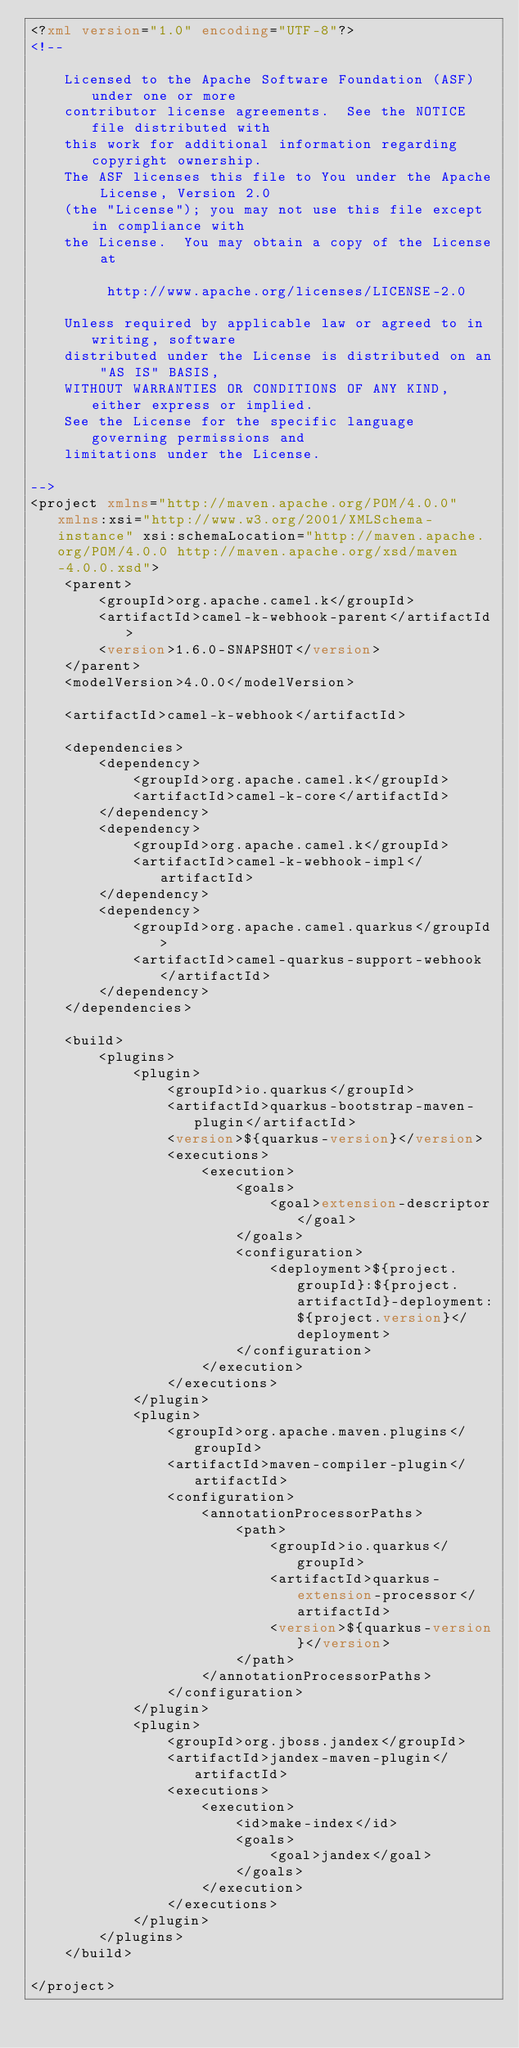<code> <loc_0><loc_0><loc_500><loc_500><_XML_><?xml version="1.0" encoding="UTF-8"?>
<!--

    Licensed to the Apache Software Foundation (ASF) under one or more
    contributor license agreements.  See the NOTICE file distributed with
    this work for additional information regarding copyright ownership.
    The ASF licenses this file to You under the Apache License, Version 2.0
    (the "License"); you may not use this file except in compliance with
    the License.  You may obtain a copy of the License at

         http://www.apache.org/licenses/LICENSE-2.0

    Unless required by applicable law or agreed to in writing, software
    distributed under the License is distributed on an "AS IS" BASIS,
    WITHOUT WARRANTIES OR CONDITIONS OF ANY KIND, either express or implied.
    See the License for the specific language governing permissions and
    limitations under the License.

-->
<project xmlns="http://maven.apache.org/POM/4.0.0" xmlns:xsi="http://www.w3.org/2001/XMLSchema-instance" xsi:schemaLocation="http://maven.apache.org/POM/4.0.0 http://maven.apache.org/xsd/maven-4.0.0.xsd">
    <parent>
        <groupId>org.apache.camel.k</groupId>
        <artifactId>camel-k-webhook-parent</artifactId>
        <version>1.6.0-SNAPSHOT</version>
    </parent>
    <modelVersion>4.0.0</modelVersion>

    <artifactId>camel-k-webhook</artifactId>

    <dependencies>
        <dependency>
            <groupId>org.apache.camel.k</groupId>
            <artifactId>camel-k-core</artifactId>
        </dependency>
        <dependency>
            <groupId>org.apache.camel.k</groupId>
            <artifactId>camel-k-webhook-impl</artifactId>
        </dependency>
        <dependency>
            <groupId>org.apache.camel.quarkus</groupId>
            <artifactId>camel-quarkus-support-webhook</artifactId>
        </dependency>
    </dependencies>

    <build>
        <plugins>
            <plugin>
                <groupId>io.quarkus</groupId>
                <artifactId>quarkus-bootstrap-maven-plugin</artifactId>
                <version>${quarkus-version}</version>
                <executions>
                    <execution>
                        <goals>
                            <goal>extension-descriptor</goal>
                        </goals>
                        <configuration>
                            <deployment>${project.groupId}:${project.artifactId}-deployment:${project.version}</deployment>
                        </configuration>
                    </execution>
                </executions>
            </plugin>
            <plugin>
                <groupId>org.apache.maven.plugins</groupId>
                <artifactId>maven-compiler-plugin</artifactId>
                <configuration>
                    <annotationProcessorPaths>
                        <path>
                            <groupId>io.quarkus</groupId>
                            <artifactId>quarkus-extension-processor</artifactId>
                            <version>${quarkus-version}</version>
                        </path>
                    </annotationProcessorPaths>
                </configuration>
            </plugin>
            <plugin>
                <groupId>org.jboss.jandex</groupId>
                <artifactId>jandex-maven-plugin</artifactId>
                <executions>
                    <execution>
                        <id>make-index</id>
                        <goals>
                            <goal>jandex</goal>
                        </goals>
                    </execution>
                </executions>
            </plugin>
        </plugins>
    </build>

</project>
</code> 